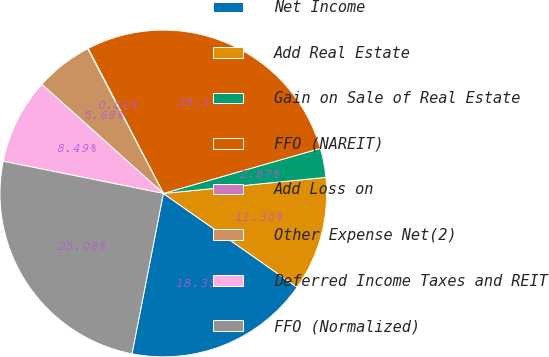Convert chart to OTSL. <chart><loc_0><loc_0><loc_500><loc_500><pie_chart><fcel>Net Income<fcel>Add Real Estate<fcel>Gain on Sale of Real Estate<fcel>FFO (NAREIT)<fcel>Add Loss on<fcel>Other Expense Net(2)<fcel>Deferred Income Taxes and REIT<fcel>FFO (Normalized)<nl><fcel>18.35%<fcel>11.3%<fcel>2.87%<fcel>28.17%<fcel>0.06%<fcel>5.68%<fcel>8.49%<fcel>25.08%<nl></chart> 